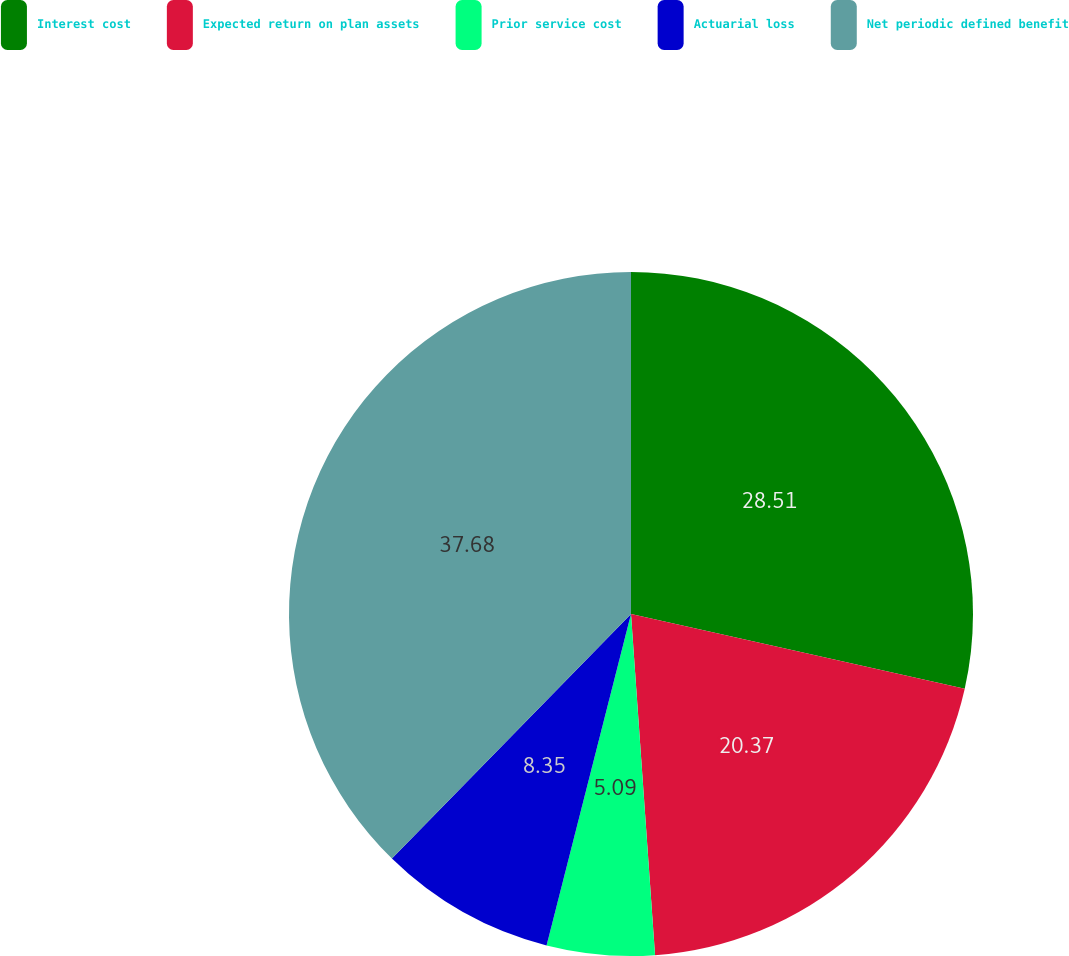Convert chart. <chart><loc_0><loc_0><loc_500><loc_500><pie_chart><fcel>Interest cost<fcel>Expected return on plan assets<fcel>Prior service cost<fcel>Actuarial loss<fcel>Net periodic defined benefit<nl><fcel>28.51%<fcel>20.37%<fcel>5.09%<fcel>8.35%<fcel>37.68%<nl></chart> 